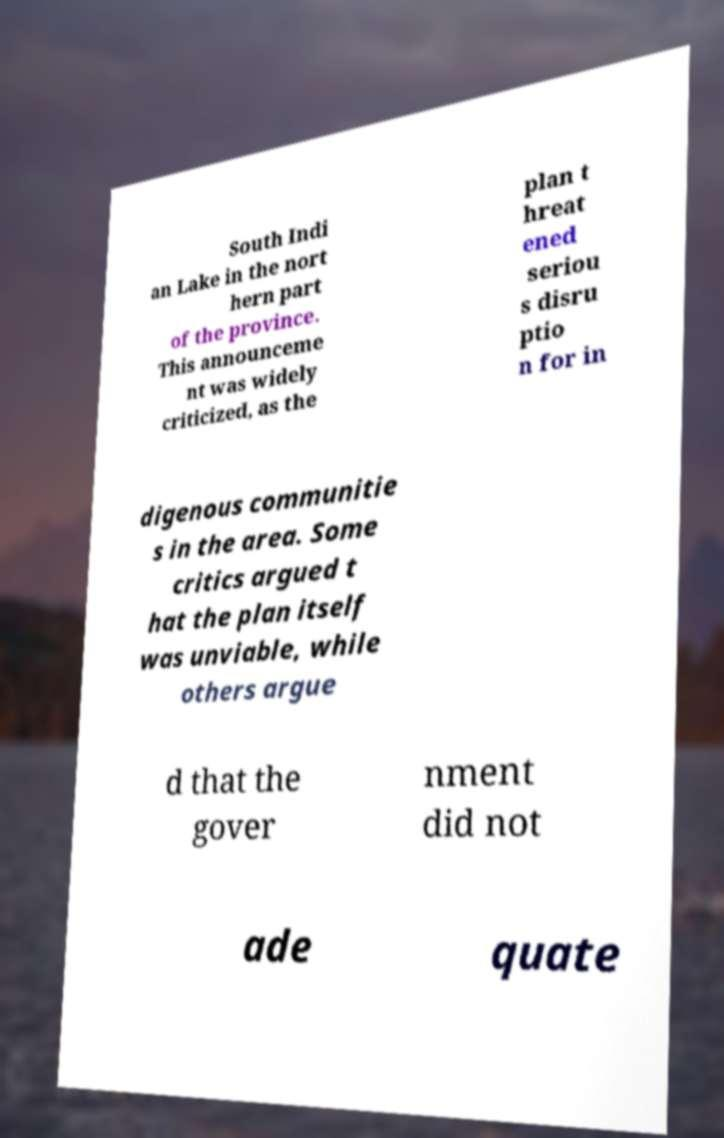Could you assist in decoding the text presented in this image and type it out clearly? South Indi an Lake in the nort hern part of the province. This announceme nt was widely criticized, as the plan t hreat ened seriou s disru ptio n for in digenous communitie s in the area. Some critics argued t hat the plan itself was unviable, while others argue d that the gover nment did not ade quate 